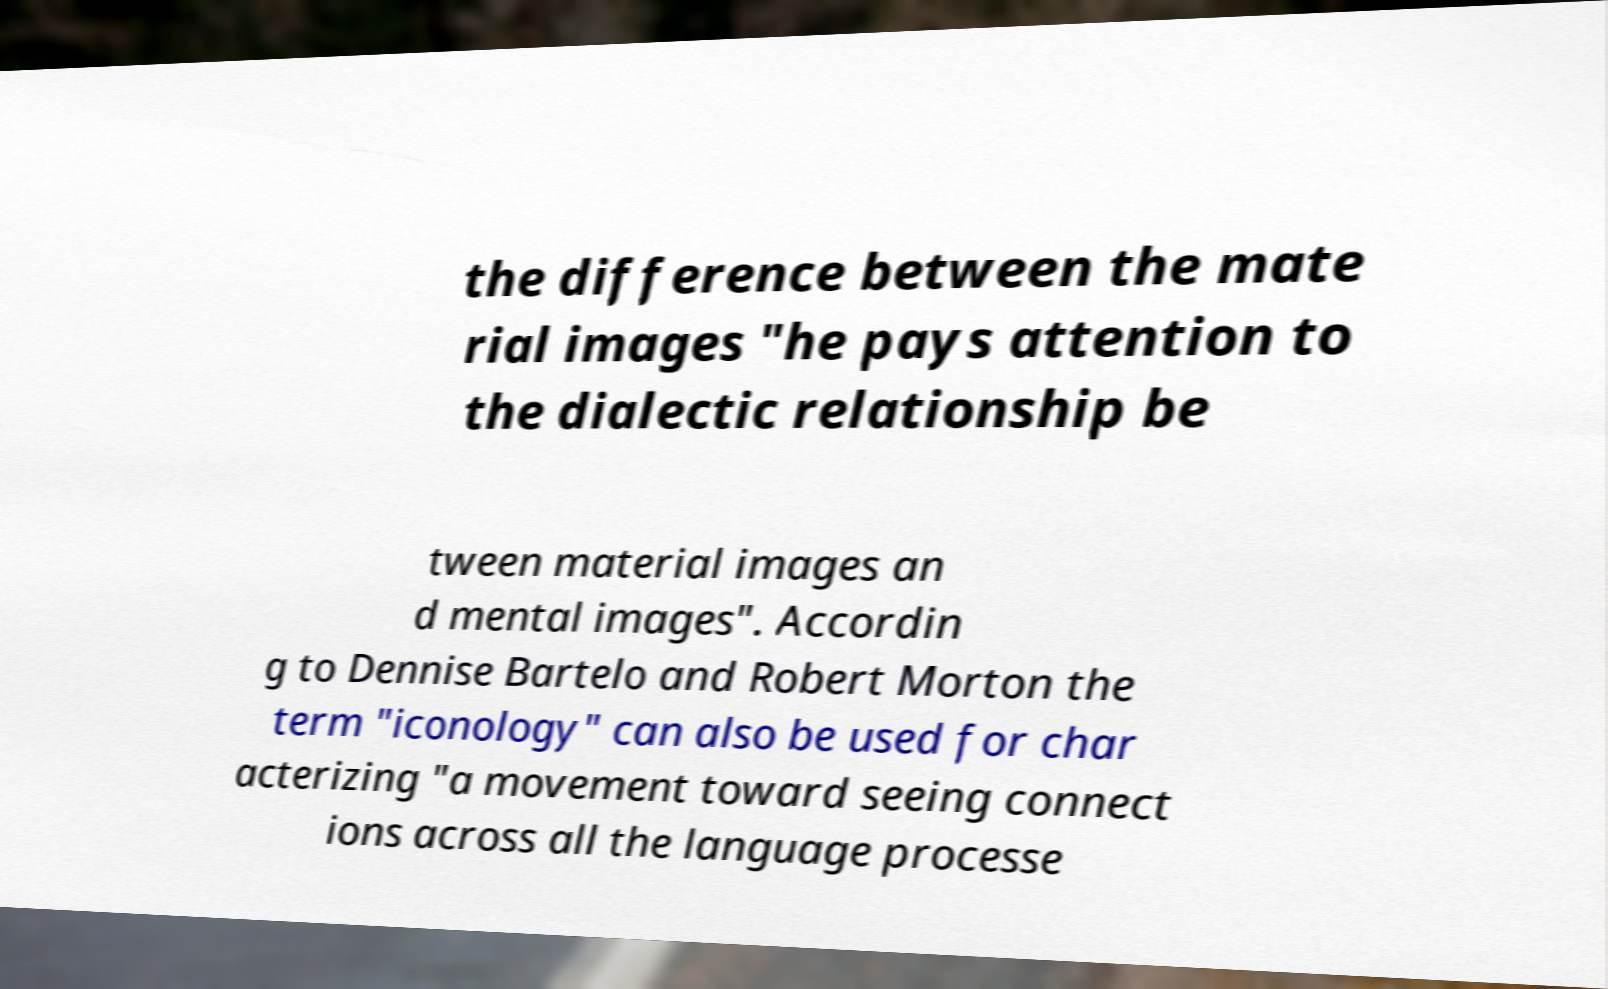Please identify and transcribe the text found in this image. the difference between the mate rial images "he pays attention to the dialectic relationship be tween material images an d mental images". Accordin g to Dennise Bartelo and Robert Morton the term "iconology" can also be used for char acterizing "a movement toward seeing connect ions across all the language processe 